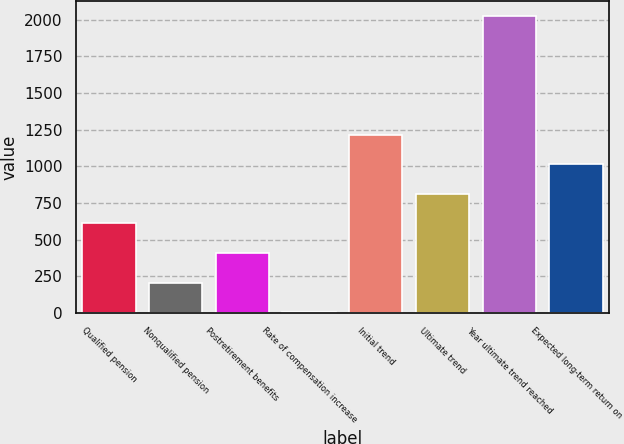Convert chart. <chart><loc_0><loc_0><loc_500><loc_500><bar_chart><fcel>Qualified pension<fcel>Nonqualified pension<fcel>Postretirement benefits<fcel>Rate of compensation increase<fcel>Initial trend<fcel>Ultimate trend<fcel>Year ultimate trend reached<fcel>Expected long-term return on<nl><fcel>609.95<fcel>205.65<fcel>407.8<fcel>3.5<fcel>1216.4<fcel>812.1<fcel>2025<fcel>1014.25<nl></chart> 